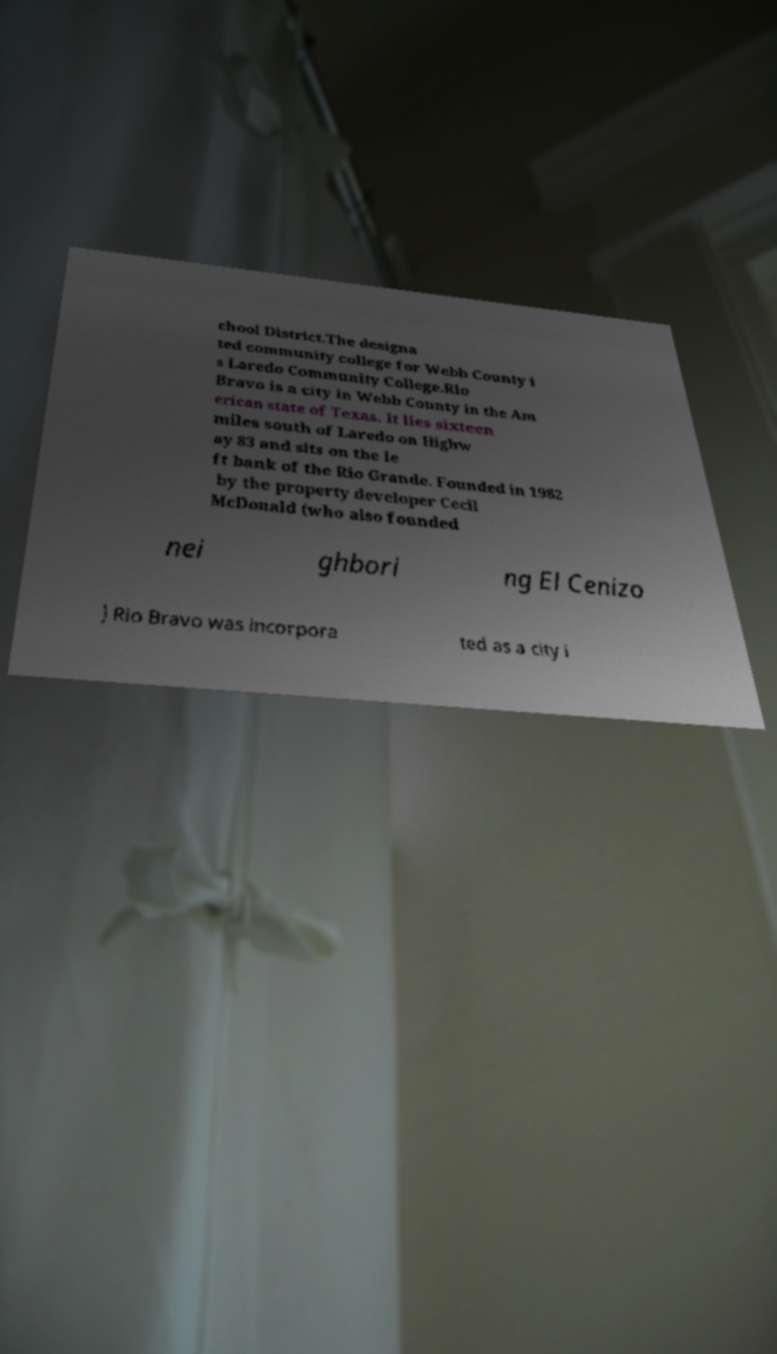Could you extract and type out the text from this image? chool District.The designa ted community college for Webb County i s Laredo Community College.Rio Bravo is a city in Webb County in the Am erican state of Texas. It lies sixteen miles south of Laredo on Highw ay 83 and sits on the le ft bank of the Rio Grande. Founded in 1982 by the property developer Cecil McDonald (who also founded nei ghbori ng El Cenizo ) Rio Bravo was incorpora ted as a city i 